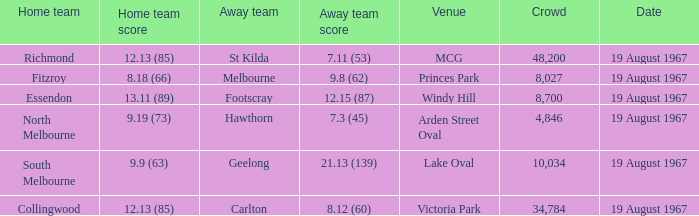What did the away team score when they were playing collingwood? 8.12 (60). 